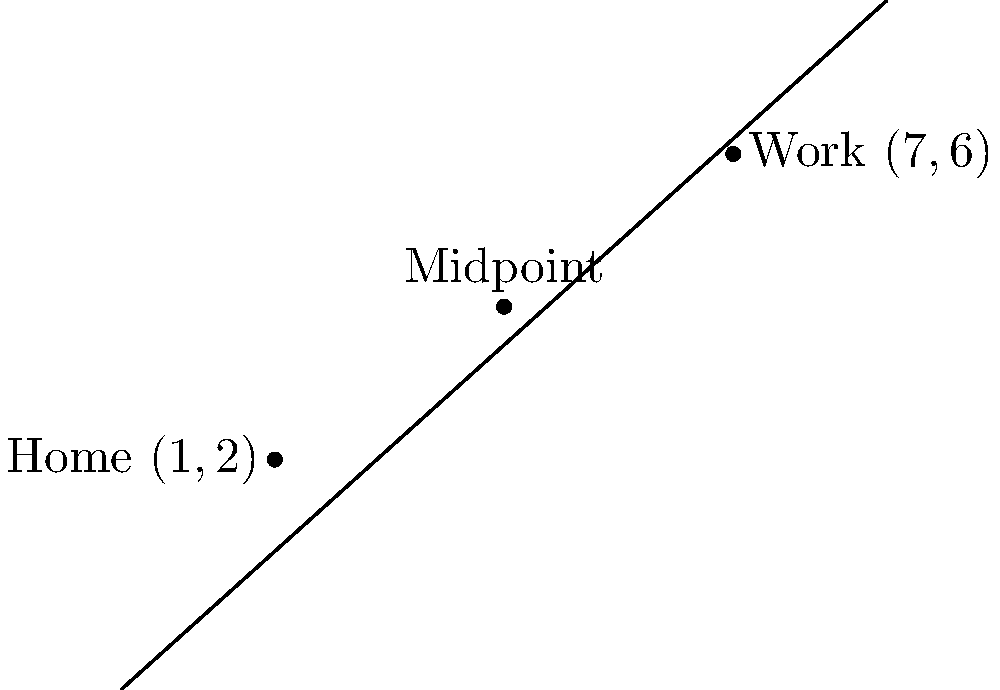After relocating to Tokyo, you find that your new home is located at coordinates $(1,2)$ and your workplace is at $(7,6)$ on a city map. To help plan your commute, you want to find a midpoint between your home and workplace. Calculate the coordinates of this midpoint. To find the midpoint between two points, we use the midpoint formula:

$$ M_x = \frac{x_1 + x_2}{2}, \quad M_y = \frac{y_1 + y_2}{2} $$

Where $(x_1, y_1)$ is the coordinate of the first point (home) and $(x_2, y_2)$ is the coordinate of the second point (workplace).

Step 1: Identify the coordinates
Home: $(x_1, y_1) = (1, 2)$
Workplace: $(x_2, y_2) = (7, 6)$

Step 2: Calculate the x-coordinate of the midpoint
$$ M_x = \frac{x_1 + x_2}{2} = \frac{1 + 7}{2} = \frac{8}{2} = 4 $$

Step 3: Calculate the y-coordinate of the midpoint
$$ M_y = \frac{y_1 + y_2}{2} = \frac{2 + 6}{2} = \frac{8}{2} = 4 $$

Step 4: Combine the results
The midpoint is $(M_x, M_y) = (4, 4)$
Answer: $(4, 4)$ 